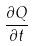Convert formula to latex. <formula><loc_0><loc_0><loc_500><loc_500>\frac { \partial Q } { \partial t }</formula> 